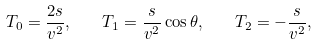<formula> <loc_0><loc_0><loc_500><loc_500>T _ { 0 } = \frac { 2 s } { v ^ { 2 } } , \quad T _ { 1 } = \frac { s } { v ^ { 2 } } \cos \theta , \quad T _ { 2 } = - \frac { s } { v ^ { 2 } } ,</formula> 